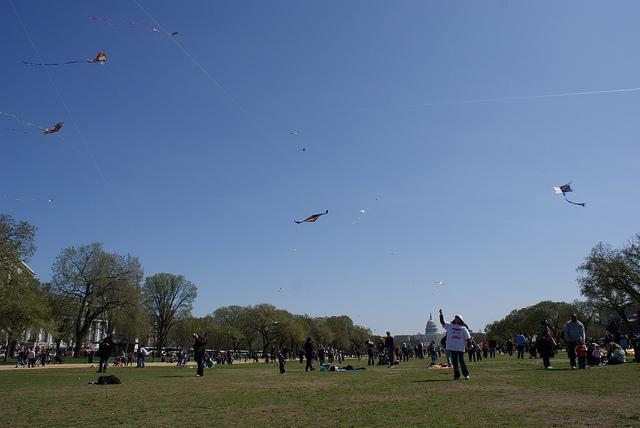What color is the sky?
Give a very brief answer. Blue. Is the photo in color?
Short answer required. Yes. Are there clouds?
Quick response, please. No. What's in the air?
Short answer required. Kites. What types of trees are there?
Quick response, please. Oak. How many people are in this picture?
Concise answer only. Many. What is the weather like in this picture?
Short answer required. Clear. How is the weather?
Quick response, please. Clear. What color is the kite to the right?
Be succinct. White. What is featured in the background of the picture?
Keep it brief. Trees. 